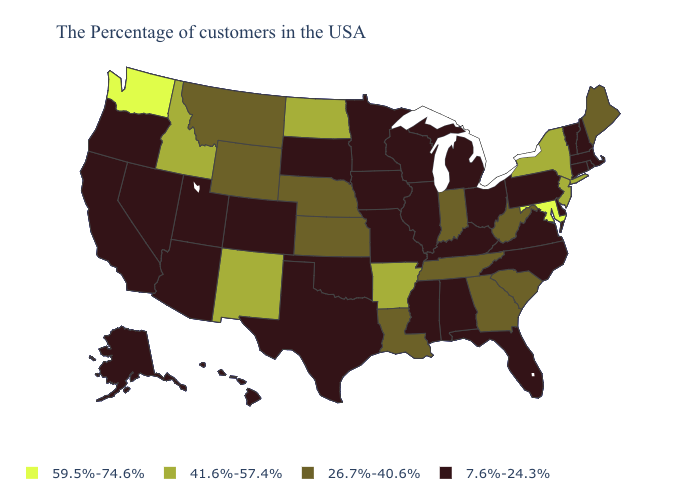What is the value of Nevada?
Short answer required. 7.6%-24.3%. Does Florida have a higher value than Rhode Island?
Be succinct. No. Name the states that have a value in the range 41.6%-57.4%?
Answer briefly. New York, New Jersey, Arkansas, North Dakota, New Mexico, Idaho. How many symbols are there in the legend?
Concise answer only. 4. What is the value of Alaska?
Answer briefly. 7.6%-24.3%. How many symbols are there in the legend?
Answer briefly. 4. Name the states that have a value in the range 41.6%-57.4%?
Quick response, please. New York, New Jersey, Arkansas, North Dakota, New Mexico, Idaho. What is the value of Hawaii?
Write a very short answer. 7.6%-24.3%. Does Colorado have the lowest value in the USA?
Give a very brief answer. Yes. What is the highest value in states that border Louisiana?
Quick response, please. 41.6%-57.4%. Does Oklahoma have a lower value than Maine?
Short answer required. Yes. What is the value of North Dakota?
Write a very short answer. 41.6%-57.4%. What is the value of Nevada?
Write a very short answer. 7.6%-24.3%. What is the highest value in the USA?
Quick response, please. 59.5%-74.6%. Name the states that have a value in the range 7.6%-24.3%?
Be succinct. Massachusetts, Rhode Island, New Hampshire, Vermont, Connecticut, Delaware, Pennsylvania, Virginia, North Carolina, Ohio, Florida, Michigan, Kentucky, Alabama, Wisconsin, Illinois, Mississippi, Missouri, Minnesota, Iowa, Oklahoma, Texas, South Dakota, Colorado, Utah, Arizona, Nevada, California, Oregon, Alaska, Hawaii. 